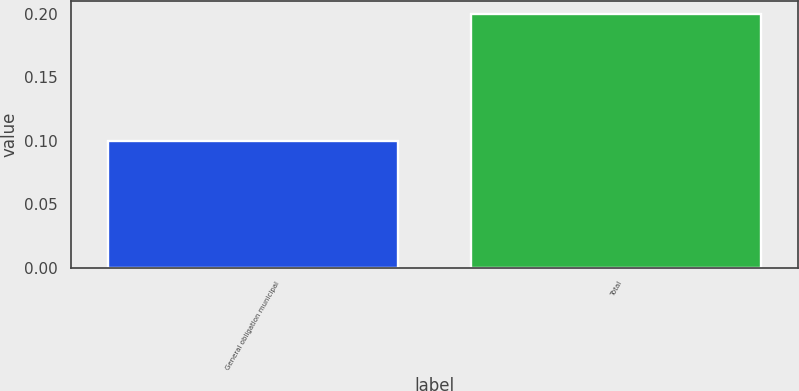Convert chart. <chart><loc_0><loc_0><loc_500><loc_500><bar_chart><fcel>General obligation municipal<fcel>Total<nl><fcel>0.1<fcel>0.2<nl></chart> 